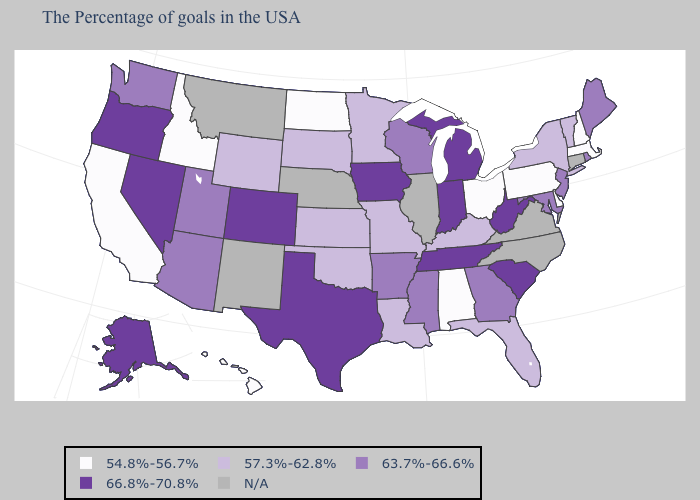What is the highest value in the USA?
Keep it brief. 66.8%-70.8%. How many symbols are there in the legend?
Write a very short answer. 5. Among the states that border Delaware , which have the highest value?
Be succinct. New Jersey, Maryland. Which states have the lowest value in the USA?
Quick response, please. Massachusetts, New Hampshire, Delaware, Pennsylvania, Ohio, Alabama, North Dakota, Idaho, California, Hawaii. Name the states that have a value in the range 66.8%-70.8%?
Keep it brief. South Carolina, West Virginia, Michigan, Indiana, Tennessee, Iowa, Texas, Colorado, Nevada, Oregon, Alaska. Does Delaware have the highest value in the USA?
Quick response, please. No. What is the value of North Carolina?
Quick response, please. N/A. What is the highest value in states that border Nevada?
Keep it brief. 66.8%-70.8%. Which states hav the highest value in the West?
Answer briefly. Colorado, Nevada, Oregon, Alaska. What is the highest value in the USA?
Be succinct. 66.8%-70.8%. What is the value of Iowa?
Write a very short answer. 66.8%-70.8%. Name the states that have a value in the range 63.7%-66.6%?
Keep it brief. Maine, Rhode Island, New Jersey, Maryland, Georgia, Wisconsin, Mississippi, Arkansas, Utah, Arizona, Washington. Among the states that border West Virginia , does Kentucky have the lowest value?
Be succinct. No. Which states have the highest value in the USA?
Keep it brief. South Carolina, West Virginia, Michigan, Indiana, Tennessee, Iowa, Texas, Colorado, Nevada, Oregon, Alaska. Is the legend a continuous bar?
Short answer required. No. 